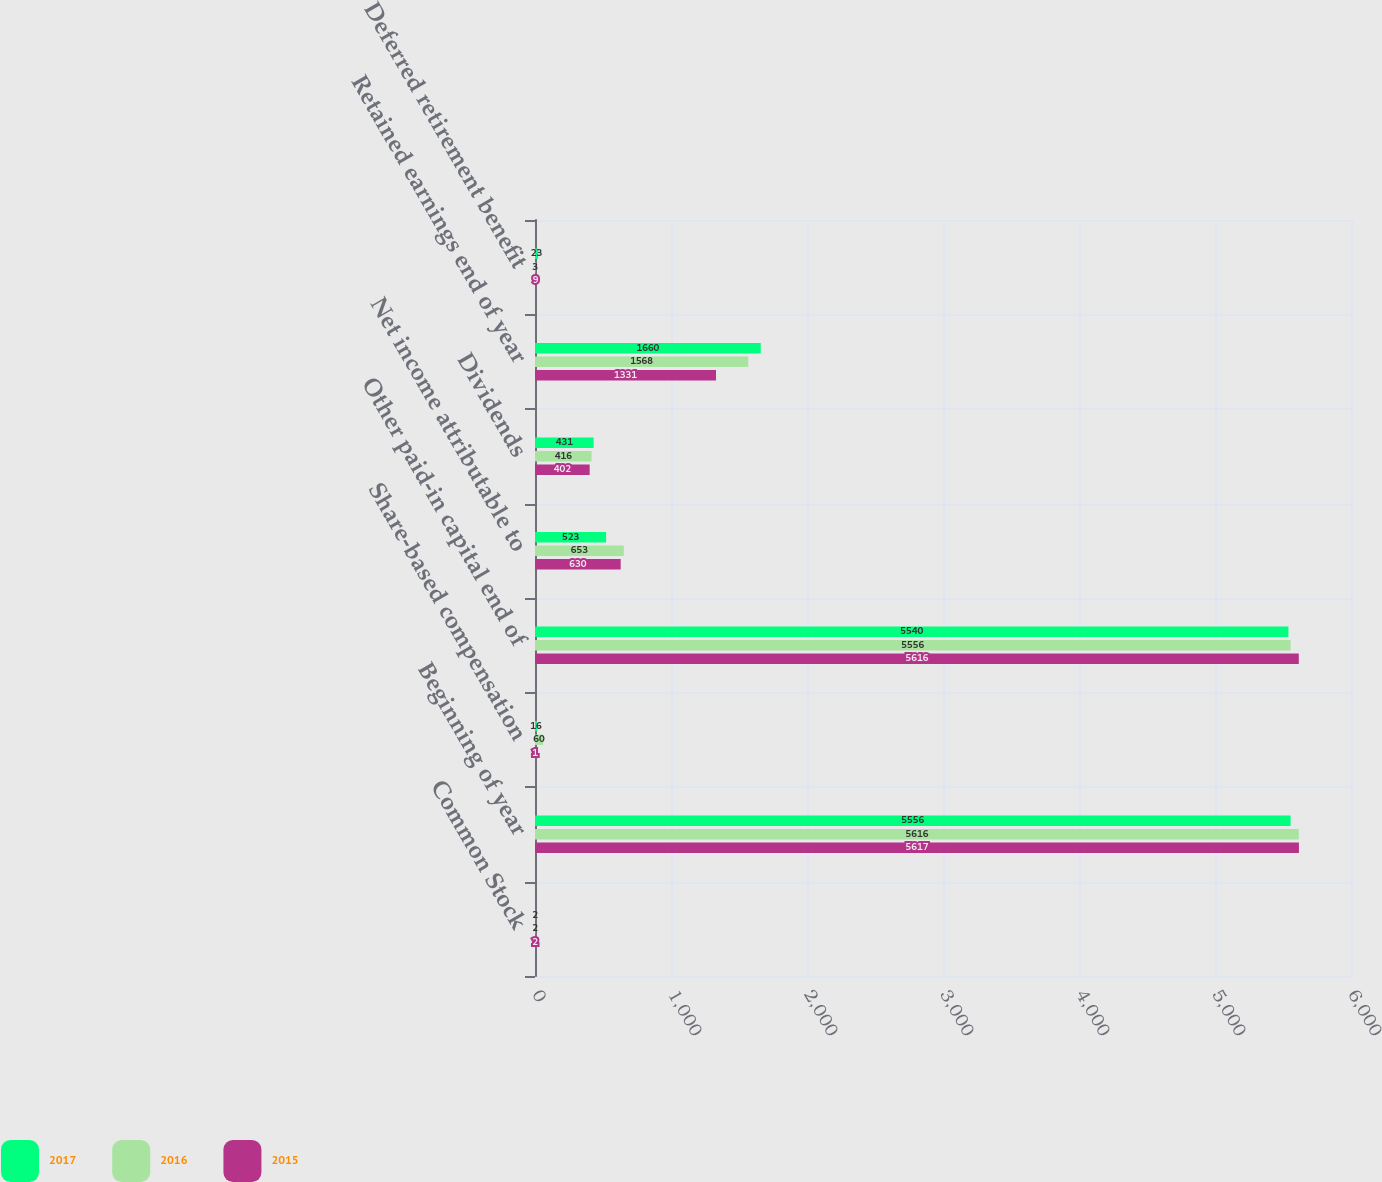Convert chart to OTSL. <chart><loc_0><loc_0><loc_500><loc_500><stacked_bar_chart><ecel><fcel>Common Stock<fcel>Beginning of year<fcel>Share-based compensation<fcel>Other paid-in capital end of<fcel>Net income attributable to<fcel>Dividends<fcel>Retained earnings end of year<fcel>Deferred retirement benefit<nl><fcel>2017<fcel>2<fcel>5556<fcel>16<fcel>5540<fcel>523<fcel>431<fcel>1660<fcel>23<nl><fcel>2016<fcel>2<fcel>5616<fcel>60<fcel>5556<fcel>653<fcel>416<fcel>1568<fcel>3<nl><fcel>2015<fcel>2<fcel>5617<fcel>1<fcel>5616<fcel>630<fcel>402<fcel>1331<fcel>9<nl></chart> 